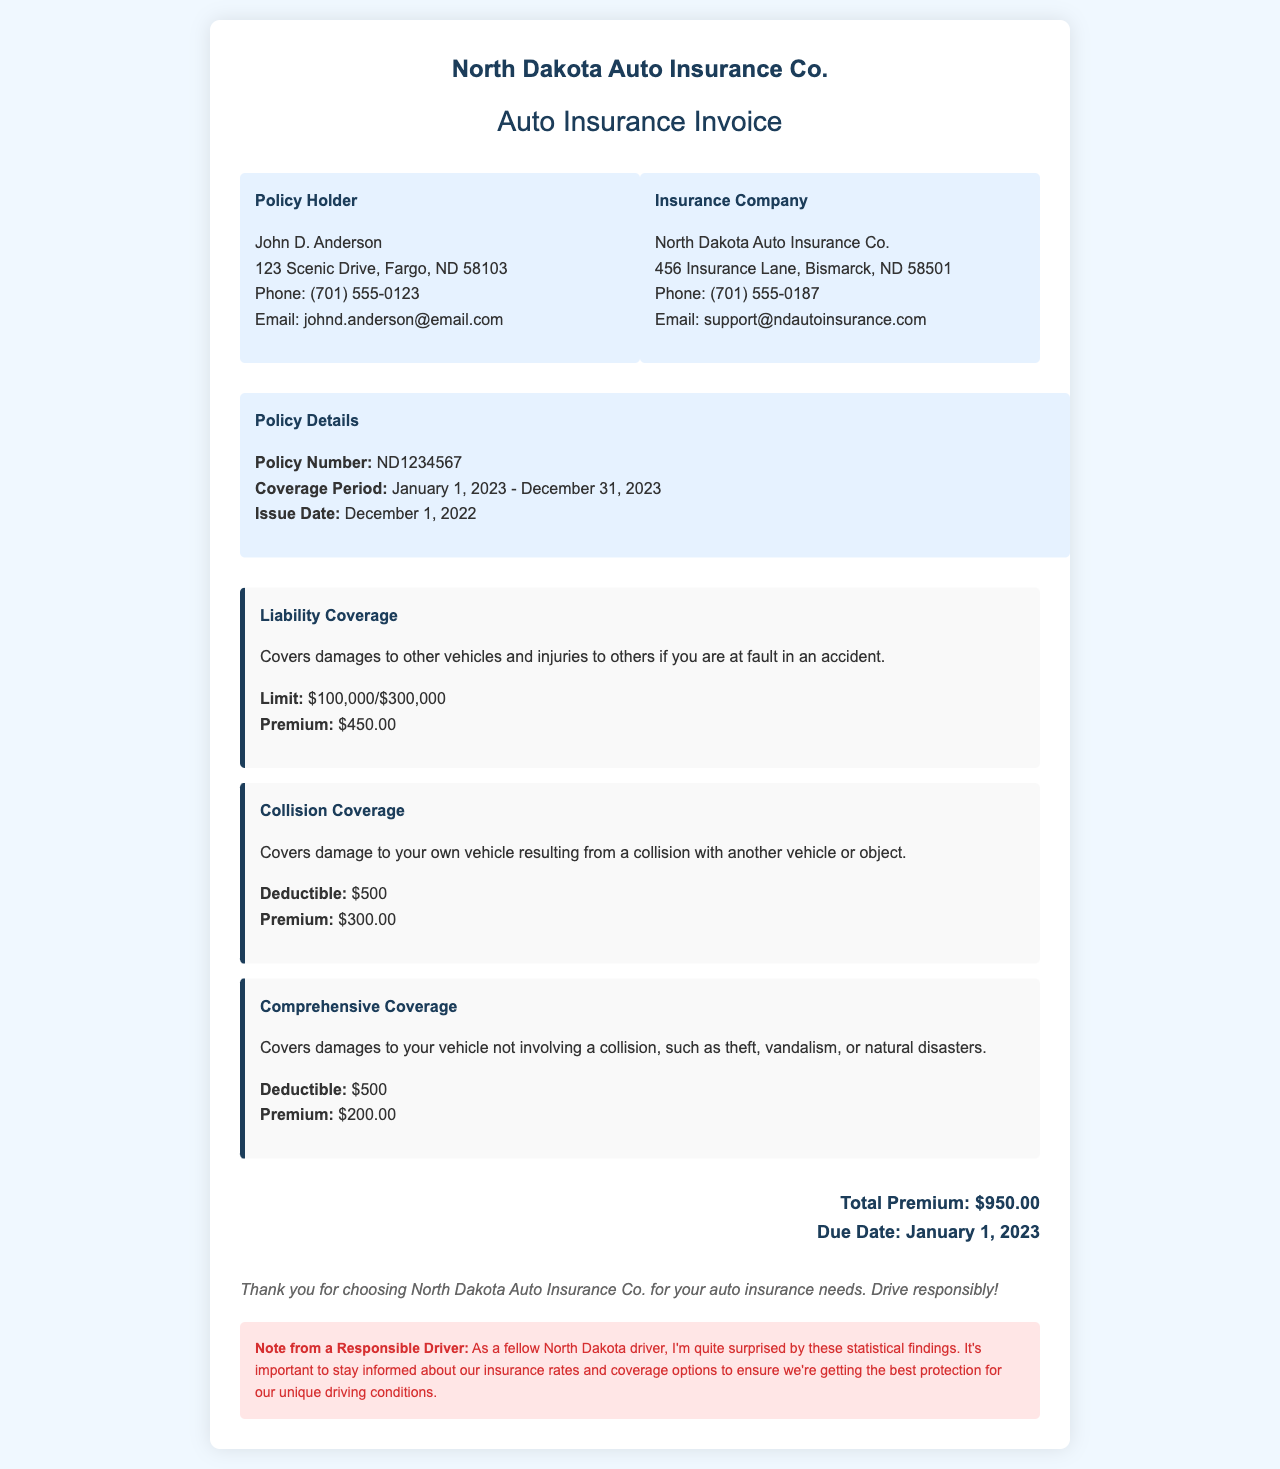What is the policy number? The policy number is a unique identifier for the insurance policy, which is ND1234567.
Answer: ND1234567 What is the total premium for the coverage period? The total premium is calculated as the sum of the premiums for all coverage options, which equals $950.00.
Answer: $950.00 Who is the policy holder? The policy holder's name is prominently displayed at the beginning of the document for identification.
Answer: John D. Anderson What is the deductible for collision coverage? The deductible amount is specified as a requirement to determine how much the insurance pays after an accident.
Answer: $500 What coverage period does this invoice cover? The coverage period defines the timeframe for which the insurance policy is valid, highlighted in the document.
Answer: January 1, 2023 - December 31, 2023 What is the premium for comprehensive coverage? The specific premium for comprehensive coverage is listed separately in the invoice.
Answer: $200.00 What is the due date for the payment? The due date is mentioned in the total section of the invoice, indicating when payment is required.
Answer: January 1, 2023 What is the limit of the liability coverage? The limit specifies the maximum amount that the insurance will pay for liability claims.
Answer: $100,000/$300,000 What is noted about responsible driving? This note emphasizes the importance of being aware of insurance rates and coverage options for drivers in North Dakota.
Answer: It's important to stay informed about our insurance rates and coverage options 